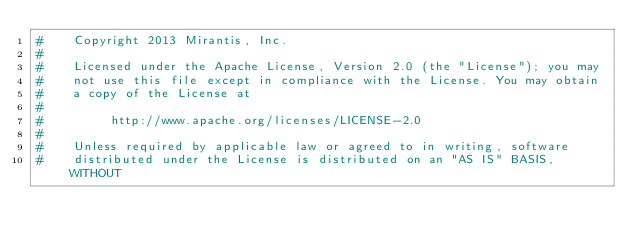Convert code to text. <code><loc_0><loc_0><loc_500><loc_500><_Ruby_>#    Copyright 2013 Mirantis, Inc.
#
#    Licensed under the Apache License, Version 2.0 (the "License"); you may
#    not use this file except in compliance with the License. You may obtain
#    a copy of the License at
#
#         http://www.apache.org/licenses/LICENSE-2.0
#
#    Unless required by applicable law or agreed to in writing, software
#    distributed under the License is distributed on an "AS IS" BASIS, WITHOUT</code> 